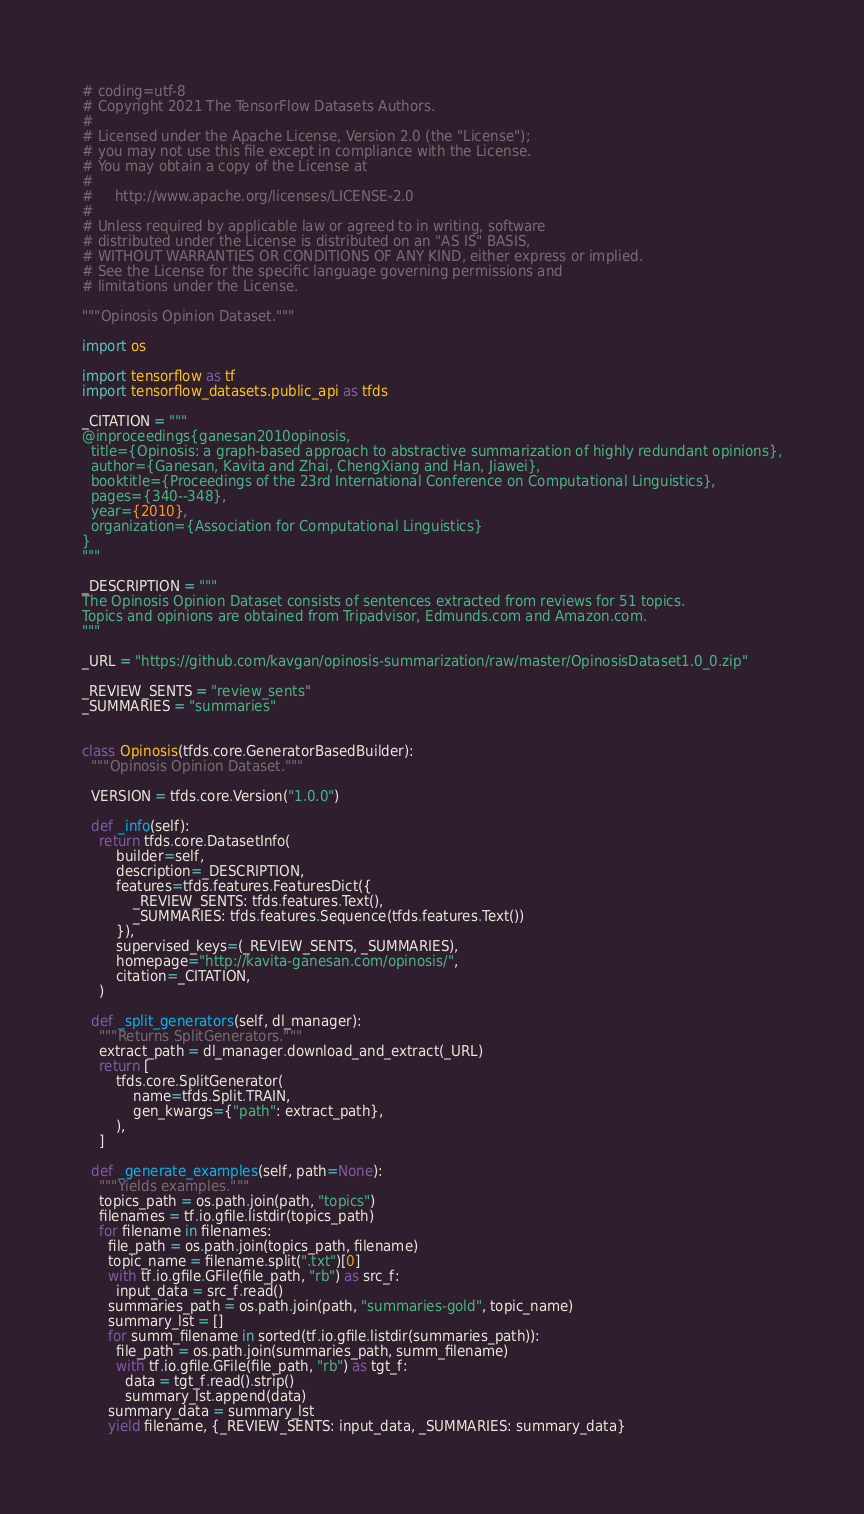<code> <loc_0><loc_0><loc_500><loc_500><_Python_># coding=utf-8
# Copyright 2021 The TensorFlow Datasets Authors.
#
# Licensed under the Apache License, Version 2.0 (the "License");
# you may not use this file except in compliance with the License.
# You may obtain a copy of the License at
#
#     http://www.apache.org/licenses/LICENSE-2.0
#
# Unless required by applicable law or agreed to in writing, software
# distributed under the License is distributed on an "AS IS" BASIS,
# WITHOUT WARRANTIES OR CONDITIONS OF ANY KIND, either express or implied.
# See the License for the specific language governing permissions and
# limitations under the License.

"""Opinosis Opinion Dataset."""

import os

import tensorflow as tf
import tensorflow_datasets.public_api as tfds

_CITATION = """
@inproceedings{ganesan2010opinosis,
  title={Opinosis: a graph-based approach to abstractive summarization of highly redundant opinions},
  author={Ganesan, Kavita and Zhai, ChengXiang and Han, Jiawei},
  booktitle={Proceedings of the 23rd International Conference on Computational Linguistics},
  pages={340--348},
  year={2010},
  organization={Association for Computational Linguistics}
}
"""

_DESCRIPTION = """
The Opinosis Opinion Dataset consists of sentences extracted from reviews for 51 topics.
Topics and opinions are obtained from Tripadvisor, Edmunds.com and Amazon.com.
"""

_URL = "https://github.com/kavgan/opinosis-summarization/raw/master/OpinosisDataset1.0_0.zip"

_REVIEW_SENTS = "review_sents"
_SUMMARIES = "summaries"


class Opinosis(tfds.core.GeneratorBasedBuilder):
  """Opinosis Opinion Dataset."""

  VERSION = tfds.core.Version("1.0.0")

  def _info(self):
    return tfds.core.DatasetInfo(
        builder=self,
        description=_DESCRIPTION,
        features=tfds.features.FeaturesDict({
            _REVIEW_SENTS: tfds.features.Text(),
            _SUMMARIES: tfds.features.Sequence(tfds.features.Text())
        }),
        supervised_keys=(_REVIEW_SENTS, _SUMMARIES),
        homepage="http://kavita-ganesan.com/opinosis/",
        citation=_CITATION,
    )

  def _split_generators(self, dl_manager):
    """Returns SplitGenerators."""
    extract_path = dl_manager.download_and_extract(_URL)
    return [
        tfds.core.SplitGenerator(
            name=tfds.Split.TRAIN,
            gen_kwargs={"path": extract_path},
        ),
    ]

  def _generate_examples(self, path=None):
    """Yields examples."""
    topics_path = os.path.join(path, "topics")
    filenames = tf.io.gfile.listdir(topics_path)
    for filename in filenames:
      file_path = os.path.join(topics_path, filename)
      topic_name = filename.split(".txt")[0]
      with tf.io.gfile.GFile(file_path, "rb") as src_f:
        input_data = src_f.read()
      summaries_path = os.path.join(path, "summaries-gold", topic_name)
      summary_lst = []
      for summ_filename in sorted(tf.io.gfile.listdir(summaries_path)):
        file_path = os.path.join(summaries_path, summ_filename)
        with tf.io.gfile.GFile(file_path, "rb") as tgt_f:
          data = tgt_f.read().strip()
          summary_lst.append(data)
      summary_data = summary_lst
      yield filename, {_REVIEW_SENTS: input_data, _SUMMARIES: summary_data}
</code> 